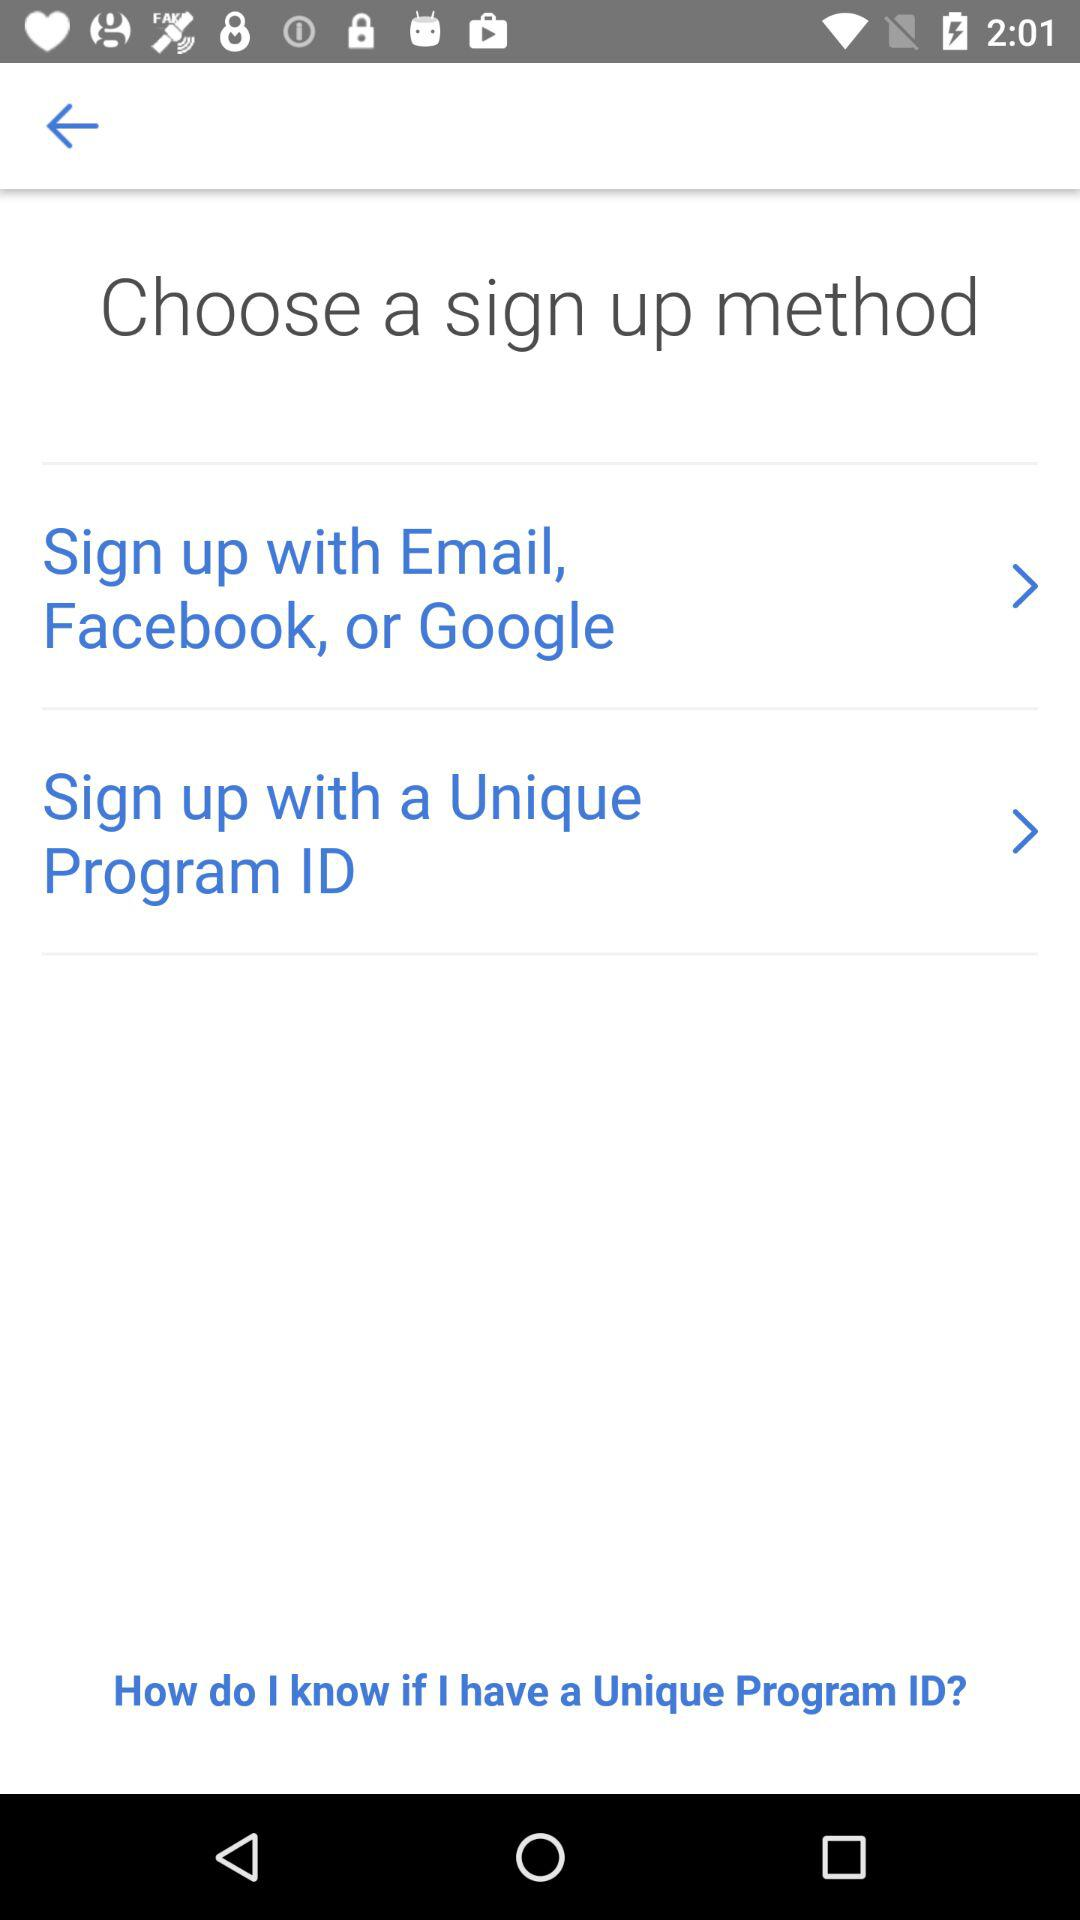Through which applications can we sign up? You can sign up through "Facebook" or "Google". 